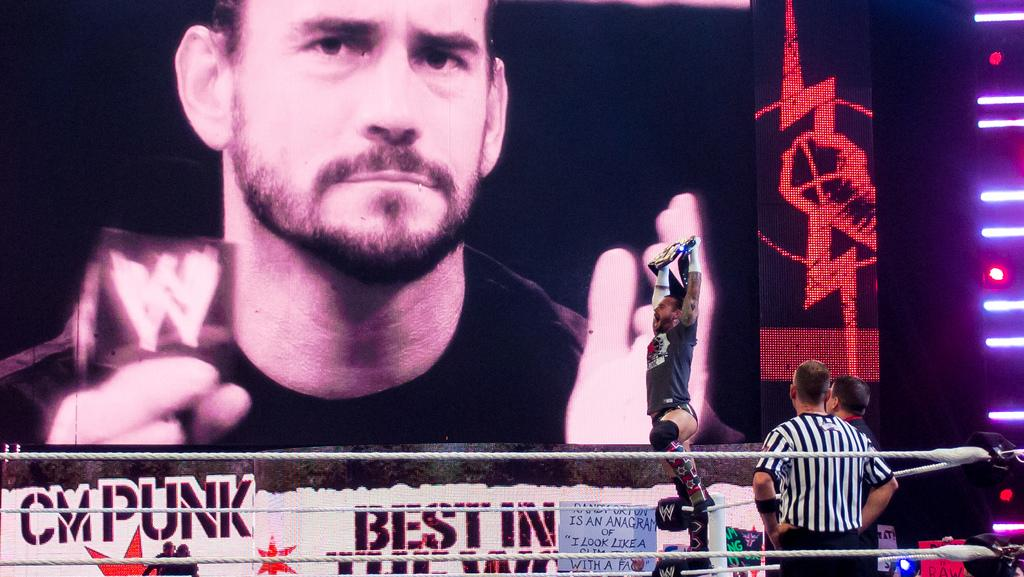What is depicted on the poster in the image? There is a poster of a man in the image. What are the people in the image doing? There are persons standing in front of the poster. Can you describe the man holding an object in the image? There is a man holding an object in his hands. What type of brush is the man using to adjust the acoustics in the image? There is no brush or mention of acoustics in the image; it features a poster of a man and people standing in front of it. Can you tell me where the sink is located in the image? There is no sink present in the image. 